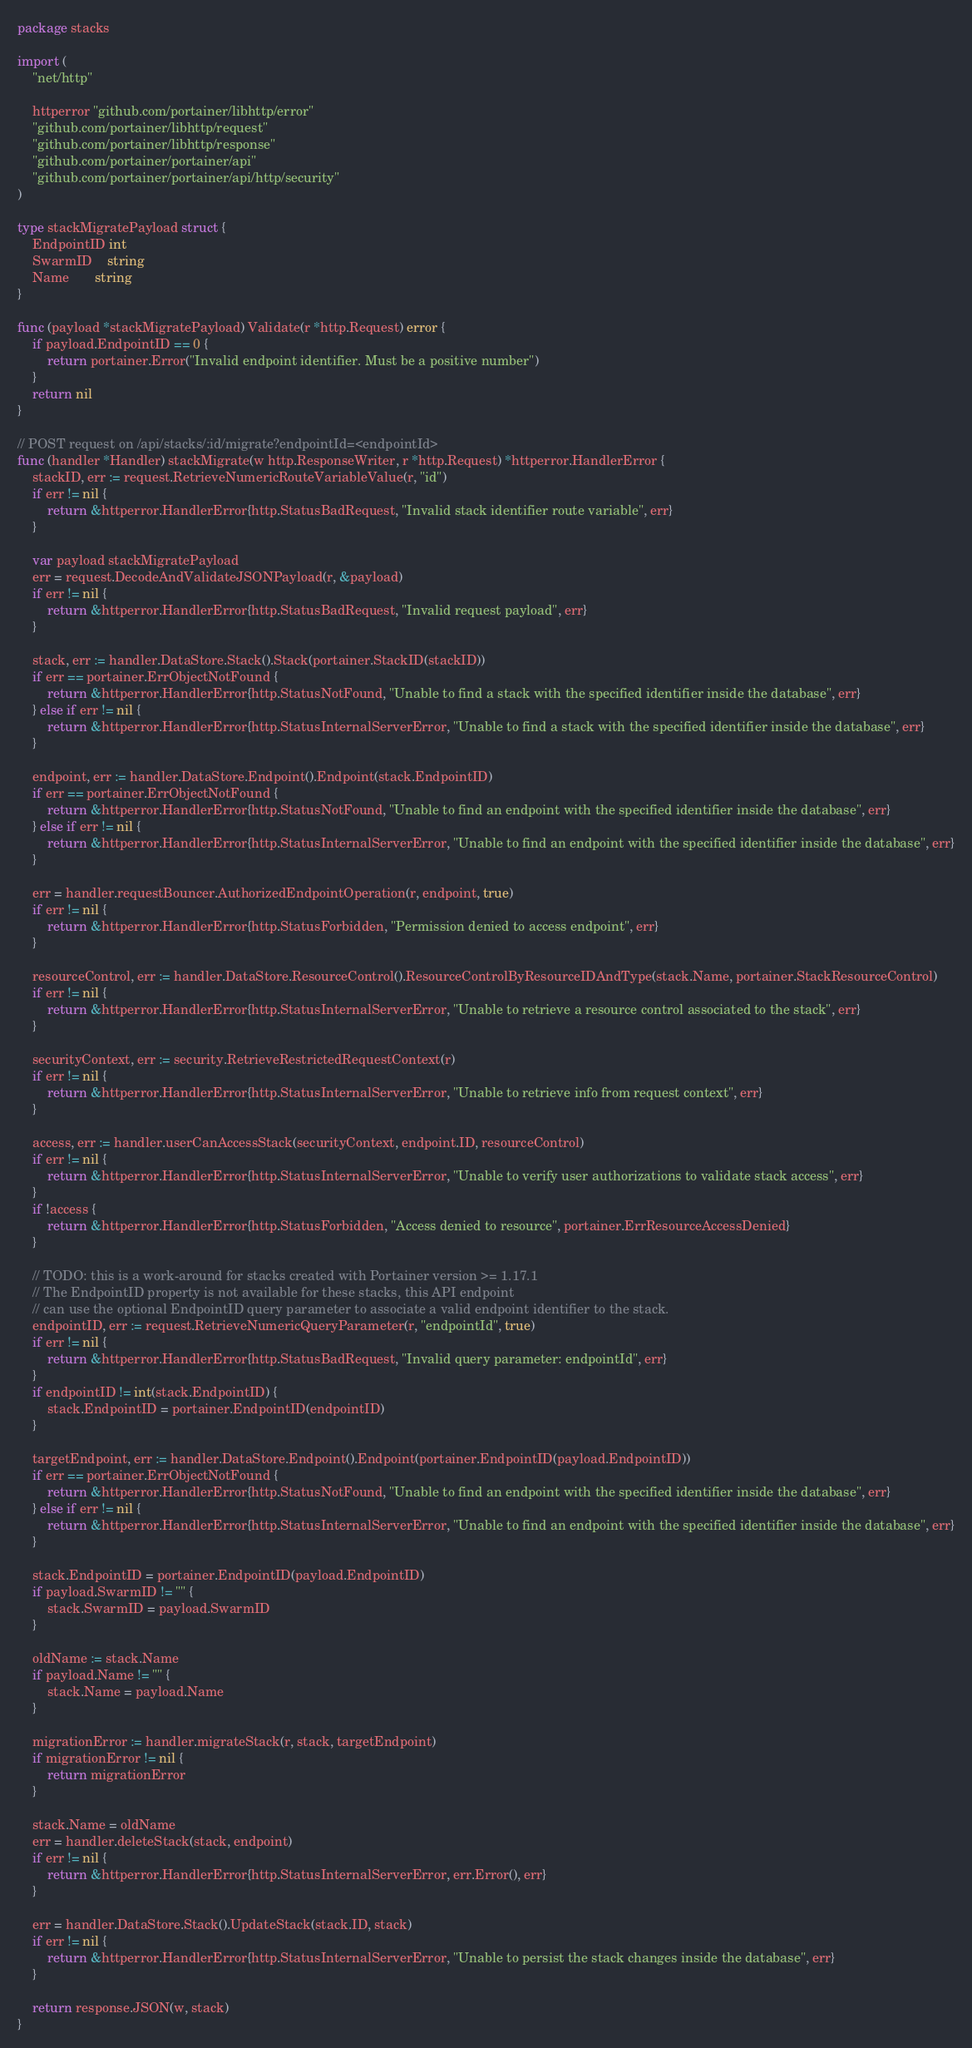<code> <loc_0><loc_0><loc_500><loc_500><_Go_>package stacks

import (
	"net/http"

	httperror "github.com/portainer/libhttp/error"
	"github.com/portainer/libhttp/request"
	"github.com/portainer/libhttp/response"
	"github.com/portainer/portainer/api"
	"github.com/portainer/portainer/api/http/security"
)

type stackMigratePayload struct {
	EndpointID int
	SwarmID    string
	Name       string
}

func (payload *stackMigratePayload) Validate(r *http.Request) error {
	if payload.EndpointID == 0 {
		return portainer.Error("Invalid endpoint identifier. Must be a positive number")
	}
	return nil
}

// POST request on /api/stacks/:id/migrate?endpointId=<endpointId>
func (handler *Handler) stackMigrate(w http.ResponseWriter, r *http.Request) *httperror.HandlerError {
	stackID, err := request.RetrieveNumericRouteVariableValue(r, "id")
	if err != nil {
		return &httperror.HandlerError{http.StatusBadRequest, "Invalid stack identifier route variable", err}
	}

	var payload stackMigratePayload
	err = request.DecodeAndValidateJSONPayload(r, &payload)
	if err != nil {
		return &httperror.HandlerError{http.StatusBadRequest, "Invalid request payload", err}
	}

	stack, err := handler.DataStore.Stack().Stack(portainer.StackID(stackID))
	if err == portainer.ErrObjectNotFound {
		return &httperror.HandlerError{http.StatusNotFound, "Unable to find a stack with the specified identifier inside the database", err}
	} else if err != nil {
		return &httperror.HandlerError{http.StatusInternalServerError, "Unable to find a stack with the specified identifier inside the database", err}
	}

	endpoint, err := handler.DataStore.Endpoint().Endpoint(stack.EndpointID)
	if err == portainer.ErrObjectNotFound {
		return &httperror.HandlerError{http.StatusNotFound, "Unable to find an endpoint with the specified identifier inside the database", err}
	} else if err != nil {
		return &httperror.HandlerError{http.StatusInternalServerError, "Unable to find an endpoint with the specified identifier inside the database", err}
	}

	err = handler.requestBouncer.AuthorizedEndpointOperation(r, endpoint, true)
	if err != nil {
		return &httperror.HandlerError{http.StatusForbidden, "Permission denied to access endpoint", err}
	}

	resourceControl, err := handler.DataStore.ResourceControl().ResourceControlByResourceIDAndType(stack.Name, portainer.StackResourceControl)
	if err != nil {
		return &httperror.HandlerError{http.StatusInternalServerError, "Unable to retrieve a resource control associated to the stack", err}
	}

	securityContext, err := security.RetrieveRestrictedRequestContext(r)
	if err != nil {
		return &httperror.HandlerError{http.StatusInternalServerError, "Unable to retrieve info from request context", err}
	}

	access, err := handler.userCanAccessStack(securityContext, endpoint.ID, resourceControl)
	if err != nil {
		return &httperror.HandlerError{http.StatusInternalServerError, "Unable to verify user authorizations to validate stack access", err}
	}
	if !access {
		return &httperror.HandlerError{http.StatusForbidden, "Access denied to resource", portainer.ErrResourceAccessDenied}
	}

	// TODO: this is a work-around for stacks created with Portainer version >= 1.17.1
	// The EndpointID property is not available for these stacks, this API endpoint
	// can use the optional EndpointID query parameter to associate a valid endpoint identifier to the stack.
	endpointID, err := request.RetrieveNumericQueryParameter(r, "endpointId", true)
	if err != nil {
		return &httperror.HandlerError{http.StatusBadRequest, "Invalid query parameter: endpointId", err}
	}
	if endpointID != int(stack.EndpointID) {
		stack.EndpointID = portainer.EndpointID(endpointID)
	}

	targetEndpoint, err := handler.DataStore.Endpoint().Endpoint(portainer.EndpointID(payload.EndpointID))
	if err == portainer.ErrObjectNotFound {
		return &httperror.HandlerError{http.StatusNotFound, "Unable to find an endpoint with the specified identifier inside the database", err}
	} else if err != nil {
		return &httperror.HandlerError{http.StatusInternalServerError, "Unable to find an endpoint with the specified identifier inside the database", err}
	}

	stack.EndpointID = portainer.EndpointID(payload.EndpointID)
	if payload.SwarmID != "" {
		stack.SwarmID = payload.SwarmID
	}

	oldName := stack.Name
	if payload.Name != "" {
		stack.Name = payload.Name
	}

	migrationError := handler.migrateStack(r, stack, targetEndpoint)
	if migrationError != nil {
		return migrationError
	}

	stack.Name = oldName
	err = handler.deleteStack(stack, endpoint)
	if err != nil {
		return &httperror.HandlerError{http.StatusInternalServerError, err.Error(), err}
	}

	err = handler.DataStore.Stack().UpdateStack(stack.ID, stack)
	if err != nil {
		return &httperror.HandlerError{http.StatusInternalServerError, "Unable to persist the stack changes inside the database", err}
	}

	return response.JSON(w, stack)
}
</code> 